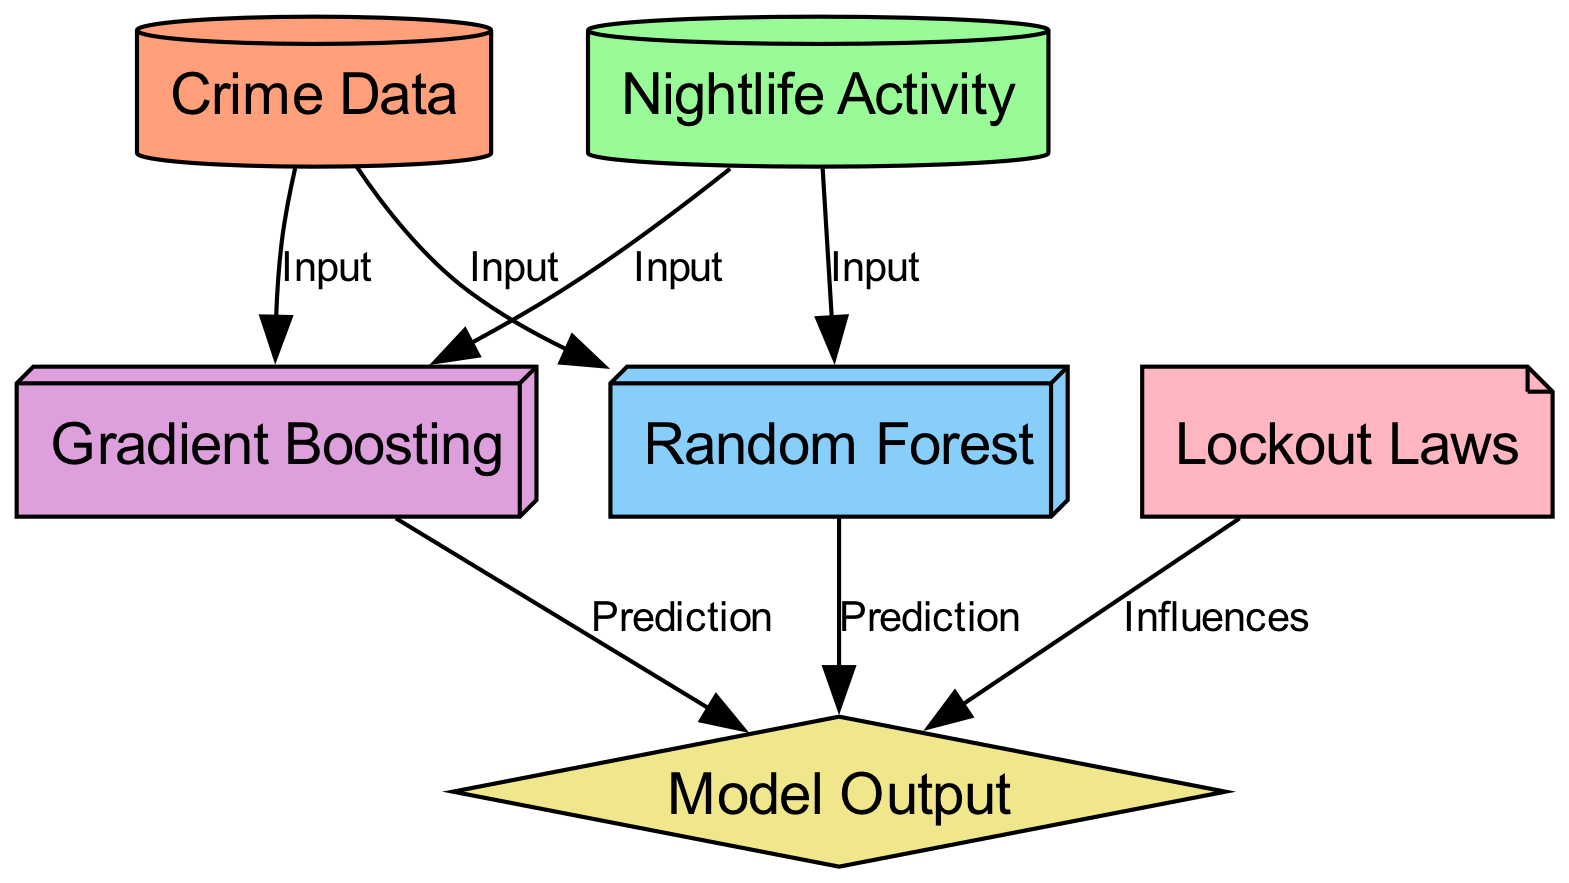What are the two types of inputs to the Random Forest model? The edges labeled as "Input" leading to the Random Forest node indicate that both "Crime Data" and "Nightlife Activity" serve as inputs to this model.
Answer: Crime Data and Nightlife Activity How many nodes are represented in the diagram? Counting all the nodes listed, there are six different nodes represented, which are: "Crime Data," "Nightlife Activity," "Random Forest," "Gradient Boosting," "Model Output," and "Lockout Laws."
Answer: Six What type of learning algorithm is displayed as the final prediction inputs? The diagram shows two ensemble learning algorithms, "Random Forest" and "Gradient Boosting," which both serve as prediction inputs leading towards the "Model Output."
Answer: Random Forest and Gradient Boosting Which node influences the result in the "Model Output"? The "Lockout Laws" node is labeled as an "Influences" edge towards the "Model Output," indicating that it plays a role in the final analysis results.
Answer: Lockout Laws What is the shape of the "Model Output" node? The diagram specifies that the "Model Output" node is represented in the shape of a diamond, which is a common way to visualize outcomes or decisions in flowcharts.
Answer: Diamond Which two nodes are inputs for Gradient Boosting? Both "Crime Data" and "Nightlife Activity" nodes feed into the "Gradient Boosting" model, as indicated by the edges labeled as "Input" that lead to this node.
Answer: Crime Data and Nightlife Activity 